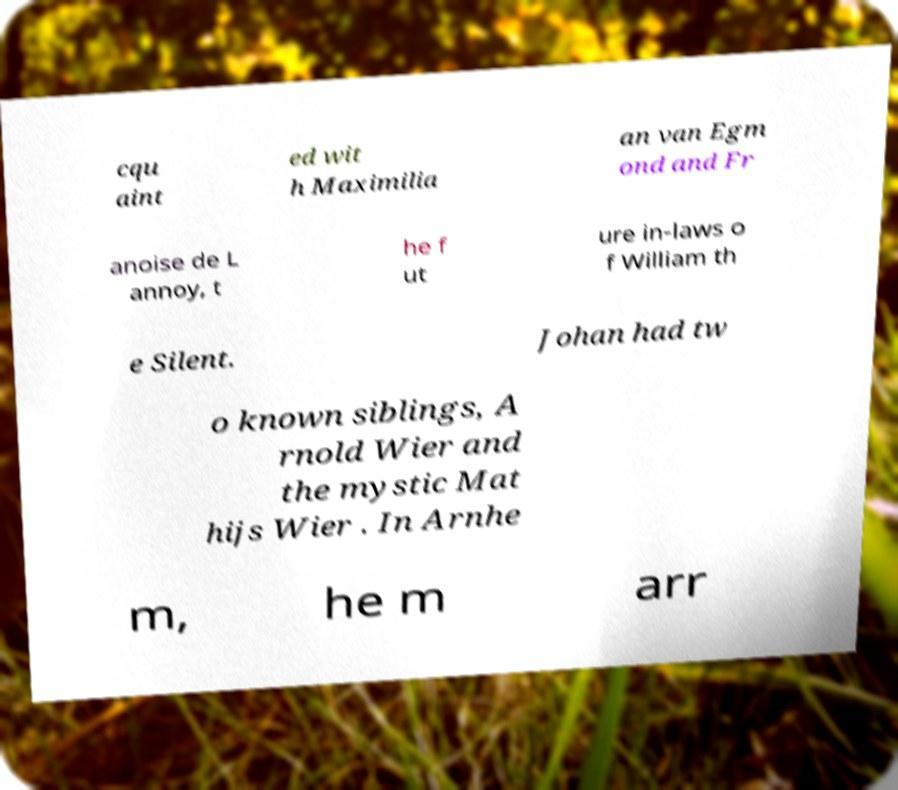Can you read and provide the text displayed in the image?This photo seems to have some interesting text. Can you extract and type it out for me? cqu aint ed wit h Maximilia an van Egm ond and Fr anoise de L annoy, t he f ut ure in-laws o f William th e Silent. Johan had tw o known siblings, A rnold Wier and the mystic Mat hijs Wier . In Arnhe m, he m arr 